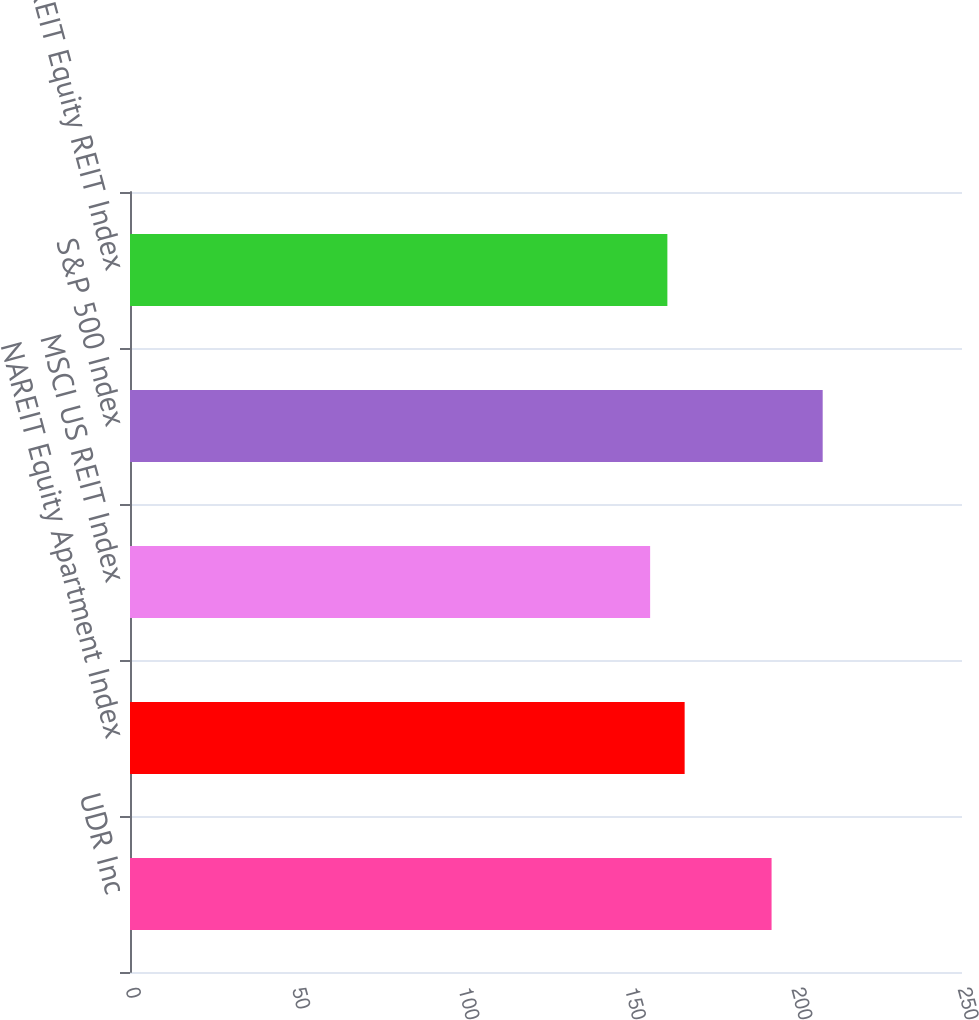Convert chart to OTSL. <chart><loc_0><loc_0><loc_500><loc_500><bar_chart><fcel>UDR Inc<fcel>NAREIT Equity Apartment Index<fcel>MSCI US REIT Index<fcel>S&P 500 Index<fcel>NAREIT Equity REIT Index<nl><fcel>192.78<fcel>166.66<fcel>156.29<fcel>208.14<fcel>161.47<nl></chart> 